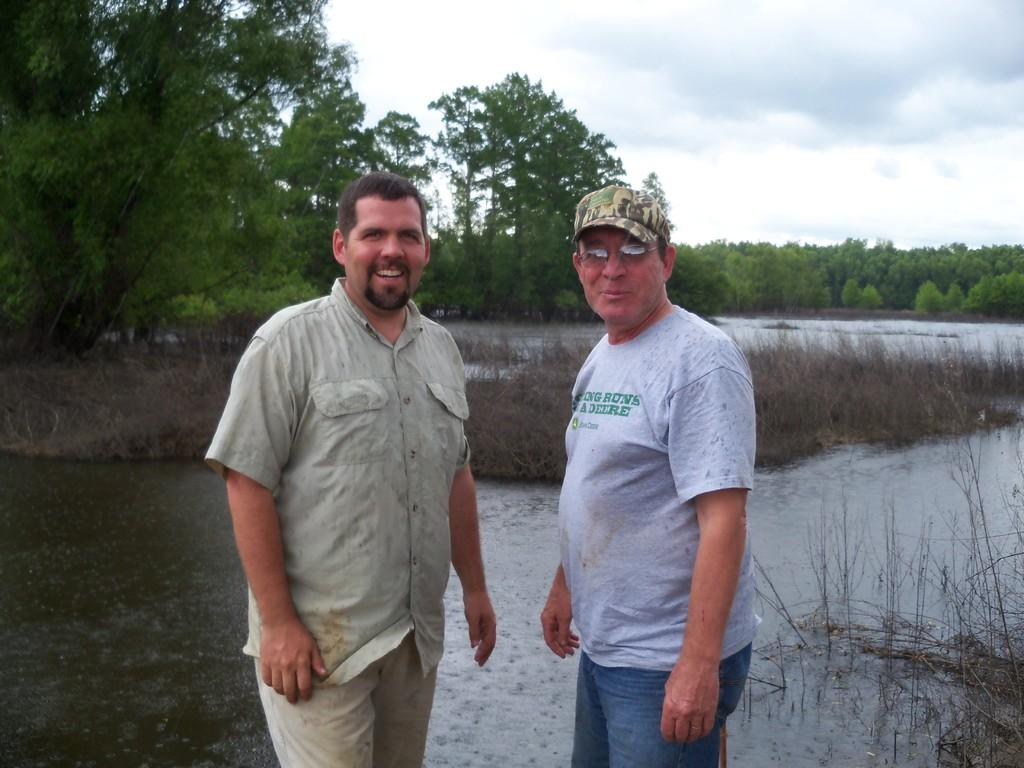How many people are in the image? There are two people standing in the center of the image. What are the people doing in the image? The two people are smiling. What can be seen in the background of the image? There is a lake, trees, and the sky visible in the background of the image. What type of faucet is visible in the image? There is no faucet present in the image. What color is the uncle's shirt in the image? There is no uncle present in the image, and therefore no shirt to describe. 